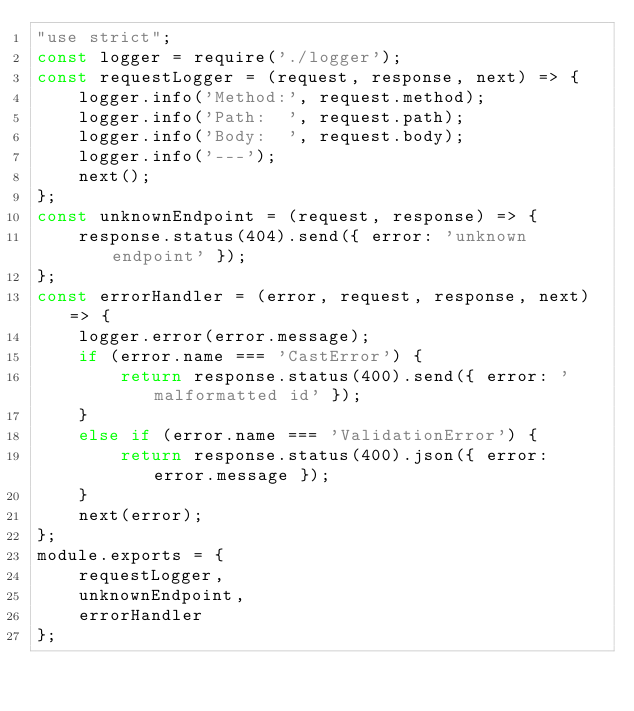<code> <loc_0><loc_0><loc_500><loc_500><_JavaScript_>"use strict";
const logger = require('./logger');
const requestLogger = (request, response, next) => {
    logger.info('Method:', request.method);
    logger.info('Path:  ', request.path);
    logger.info('Body:  ', request.body);
    logger.info('---');
    next();
};
const unknownEndpoint = (request, response) => {
    response.status(404).send({ error: 'unknown endpoint' });
};
const errorHandler = (error, request, response, next) => {
    logger.error(error.message);
    if (error.name === 'CastError') {
        return response.status(400).send({ error: 'malformatted id' });
    }
    else if (error.name === 'ValidationError') {
        return response.status(400).json({ error: error.message });
    }
    next(error);
};
module.exports = {
    requestLogger,
    unknownEndpoint,
    errorHandler
};
</code> 